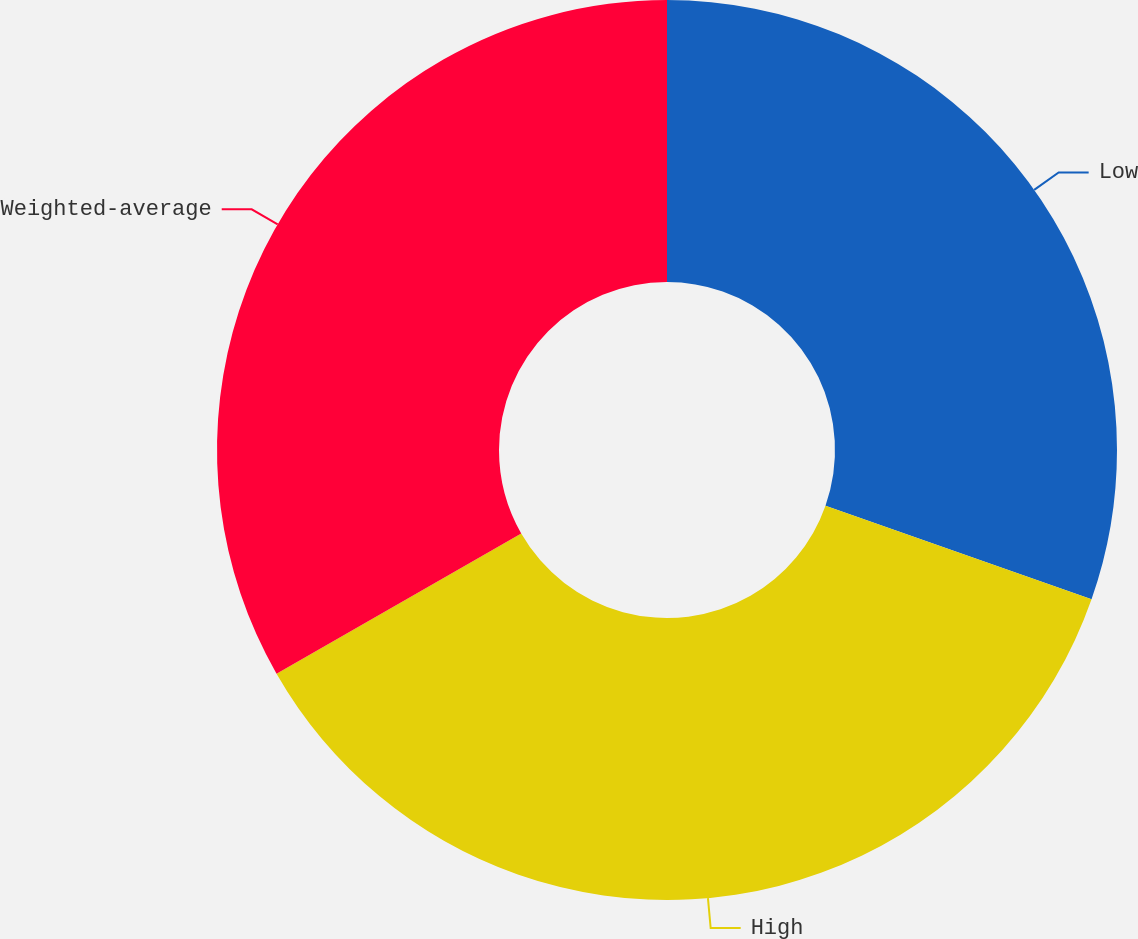<chart> <loc_0><loc_0><loc_500><loc_500><pie_chart><fcel>Low<fcel>High<fcel>Weighted-average<nl><fcel>30.38%<fcel>36.34%<fcel>33.28%<nl></chart> 